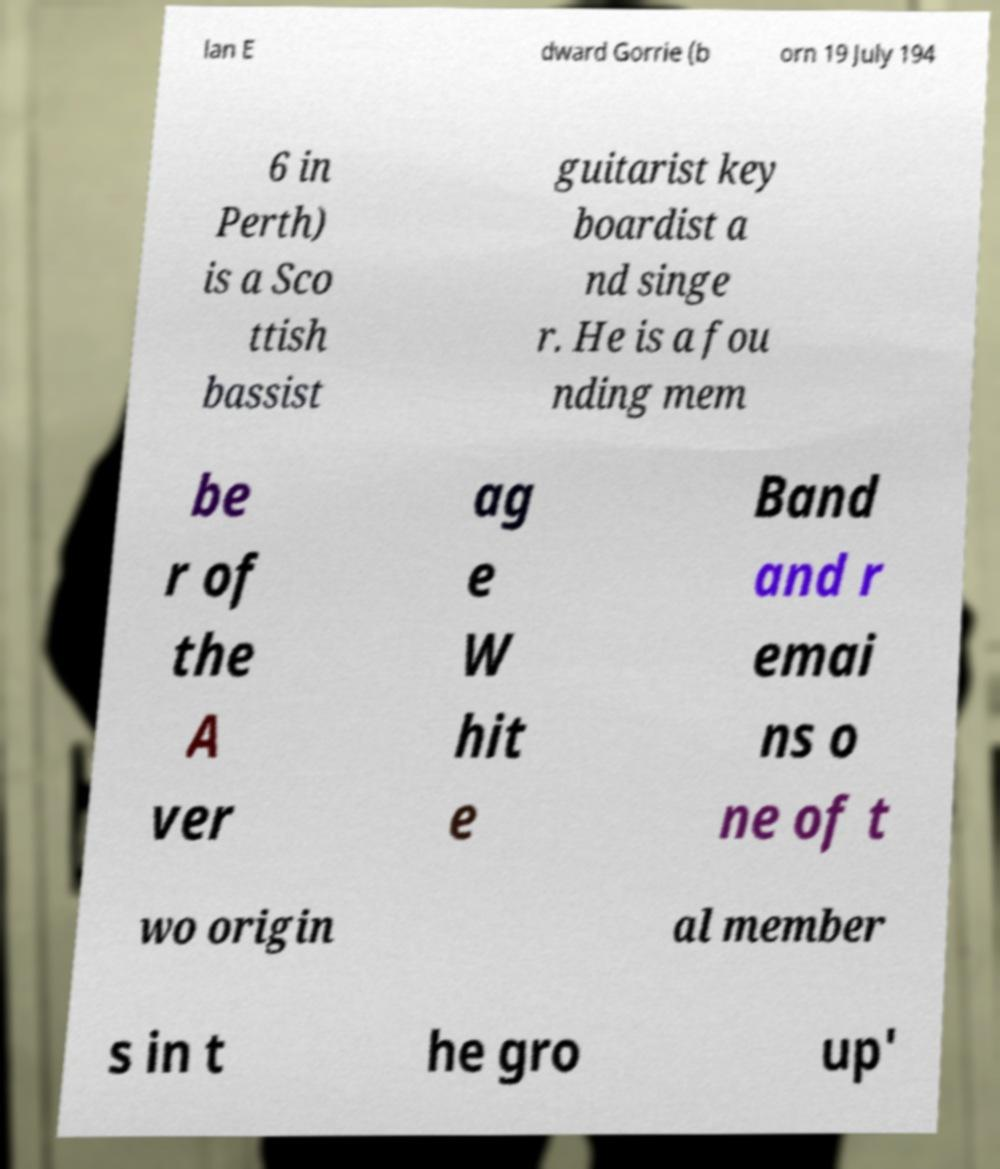Please identify and transcribe the text found in this image. lan E dward Gorrie (b orn 19 July 194 6 in Perth) is a Sco ttish bassist guitarist key boardist a nd singe r. He is a fou nding mem be r of the A ver ag e W hit e Band and r emai ns o ne of t wo origin al member s in t he gro up' 